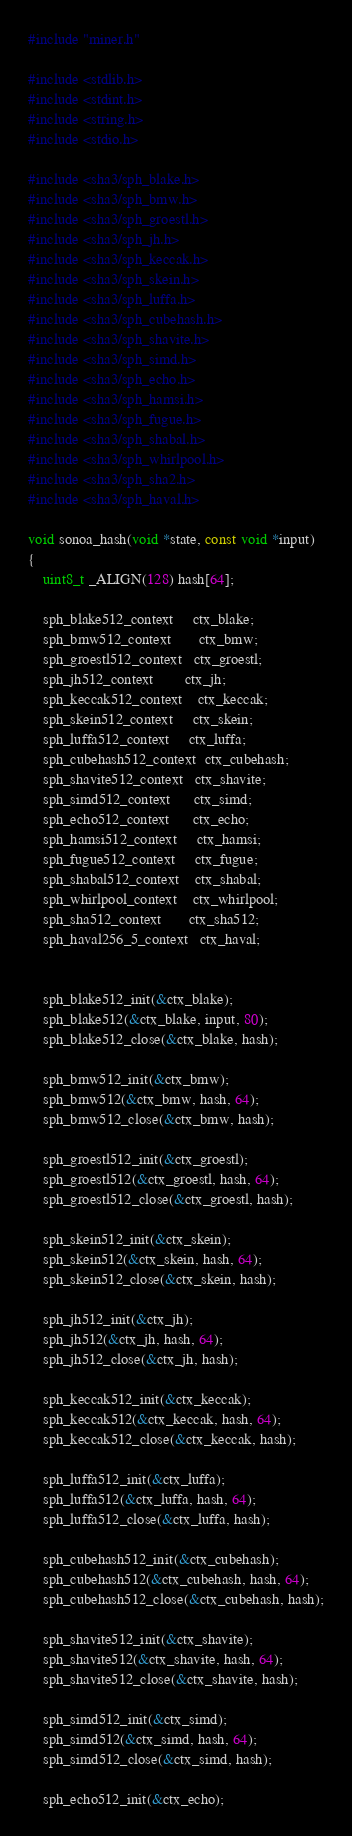<code> <loc_0><loc_0><loc_500><loc_500><_C_>#include "miner.h"

#include <stdlib.h>
#include <stdint.h>
#include <string.h>
#include <stdio.h>

#include <sha3/sph_blake.h>
#include <sha3/sph_bmw.h>
#include <sha3/sph_groestl.h>
#include <sha3/sph_jh.h>
#include <sha3/sph_keccak.h>
#include <sha3/sph_skein.h>
#include <sha3/sph_luffa.h>
#include <sha3/sph_cubehash.h>
#include <sha3/sph_shavite.h>
#include <sha3/sph_simd.h>
#include <sha3/sph_echo.h>
#include <sha3/sph_hamsi.h>
#include <sha3/sph_fugue.h>
#include <sha3/sph_shabal.h>
#include <sha3/sph_whirlpool.h>
#include <sha3/sph_sha2.h>
#include <sha3/sph_haval.h>

void sonoa_hash(void *state, const void *input)
{
	uint8_t _ALIGN(128) hash[64];

	sph_blake512_context     ctx_blake;
	sph_bmw512_context       ctx_bmw;
	sph_groestl512_context   ctx_groestl;
	sph_jh512_context        ctx_jh;
	sph_keccak512_context    ctx_keccak;
	sph_skein512_context     ctx_skein;
	sph_luffa512_context     ctx_luffa;
	sph_cubehash512_context  ctx_cubehash;
	sph_shavite512_context   ctx_shavite;
	sph_simd512_context      ctx_simd;
	sph_echo512_context      ctx_echo;
	sph_hamsi512_context     ctx_hamsi;
	sph_fugue512_context     ctx_fugue;
	sph_shabal512_context    ctx_shabal;
	sph_whirlpool_context    ctx_whirlpool;
	sph_sha512_context       ctx_sha512;
	sph_haval256_5_context   ctx_haval;


	sph_blake512_init(&ctx_blake);
	sph_blake512(&ctx_blake, input, 80);
	sph_blake512_close(&ctx_blake, hash);

	sph_bmw512_init(&ctx_bmw);
	sph_bmw512(&ctx_bmw, hash, 64);
	sph_bmw512_close(&ctx_bmw, hash);

	sph_groestl512_init(&ctx_groestl);
	sph_groestl512(&ctx_groestl, hash, 64);
	sph_groestl512_close(&ctx_groestl, hash);

	sph_skein512_init(&ctx_skein);
	sph_skein512(&ctx_skein, hash, 64);
	sph_skein512_close(&ctx_skein, hash);

	sph_jh512_init(&ctx_jh);
	sph_jh512(&ctx_jh, hash, 64);
	sph_jh512_close(&ctx_jh, hash);

	sph_keccak512_init(&ctx_keccak);
	sph_keccak512(&ctx_keccak, hash, 64);
	sph_keccak512_close(&ctx_keccak, hash);

	sph_luffa512_init(&ctx_luffa);
	sph_luffa512(&ctx_luffa, hash, 64);
	sph_luffa512_close(&ctx_luffa, hash);

	sph_cubehash512_init(&ctx_cubehash);
	sph_cubehash512(&ctx_cubehash, hash, 64);
	sph_cubehash512_close(&ctx_cubehash, hash);

	sph_shavite512_init(&ctx_shavite);
	sph_shavite512(&ctx_shavite, hash, 64);
	sph_shavite512_close(&ctx_shavite, hash);

	sph_simd512_init(&ctx_simd);
	sph_simd512(&ctx_simd, hash, 64);
	sph_simd512_close(&ctx_simd, hash);

	sph_echo512_init(&ctx_echo);</code> 